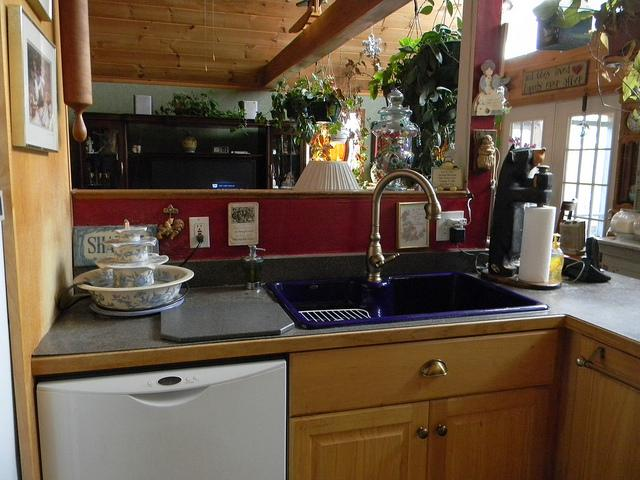What is on top of the counter? Please explain your reasoning. sink. It's actually embedded in it. the other options don't appear in this image. 